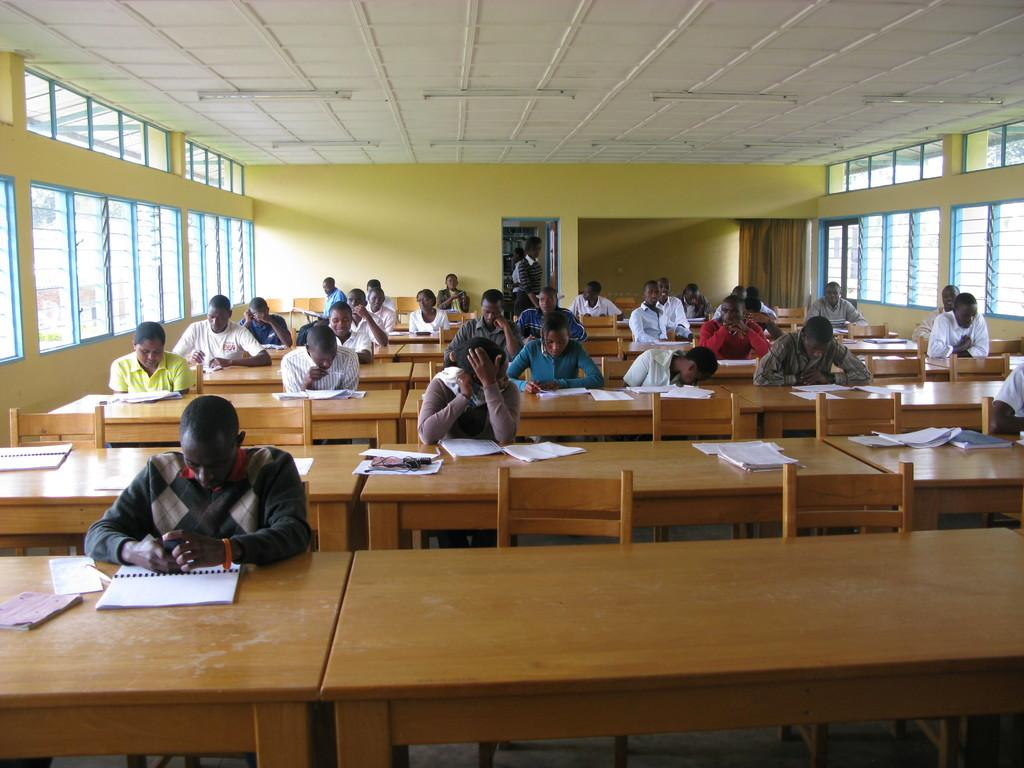Where was the image taken? The image was taken inside a room. What are the people in the image doing? The people in the image are sitting on chairs and writing on papers. What type of hen can be seen walking on the ground in the image? There is no hen or ground present in the image; it was taken inside a room with people sitting on chairs and writing on papers. 